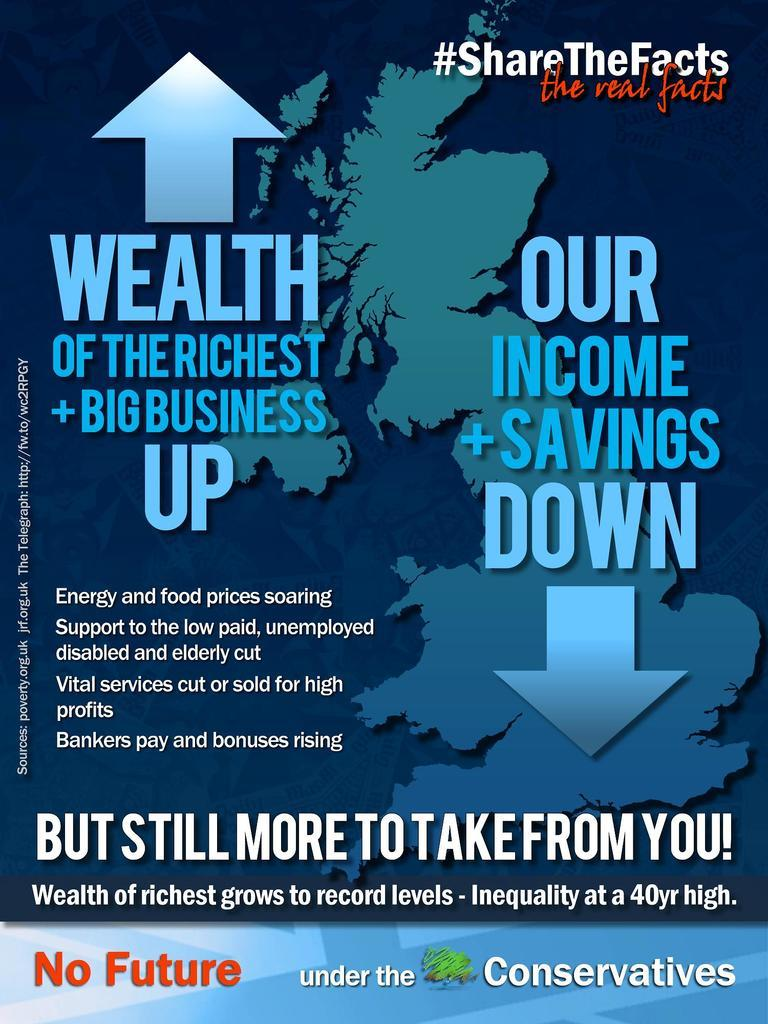<image>
Share a concise interpretation of the image provided. A poster talking about how there's no future. 